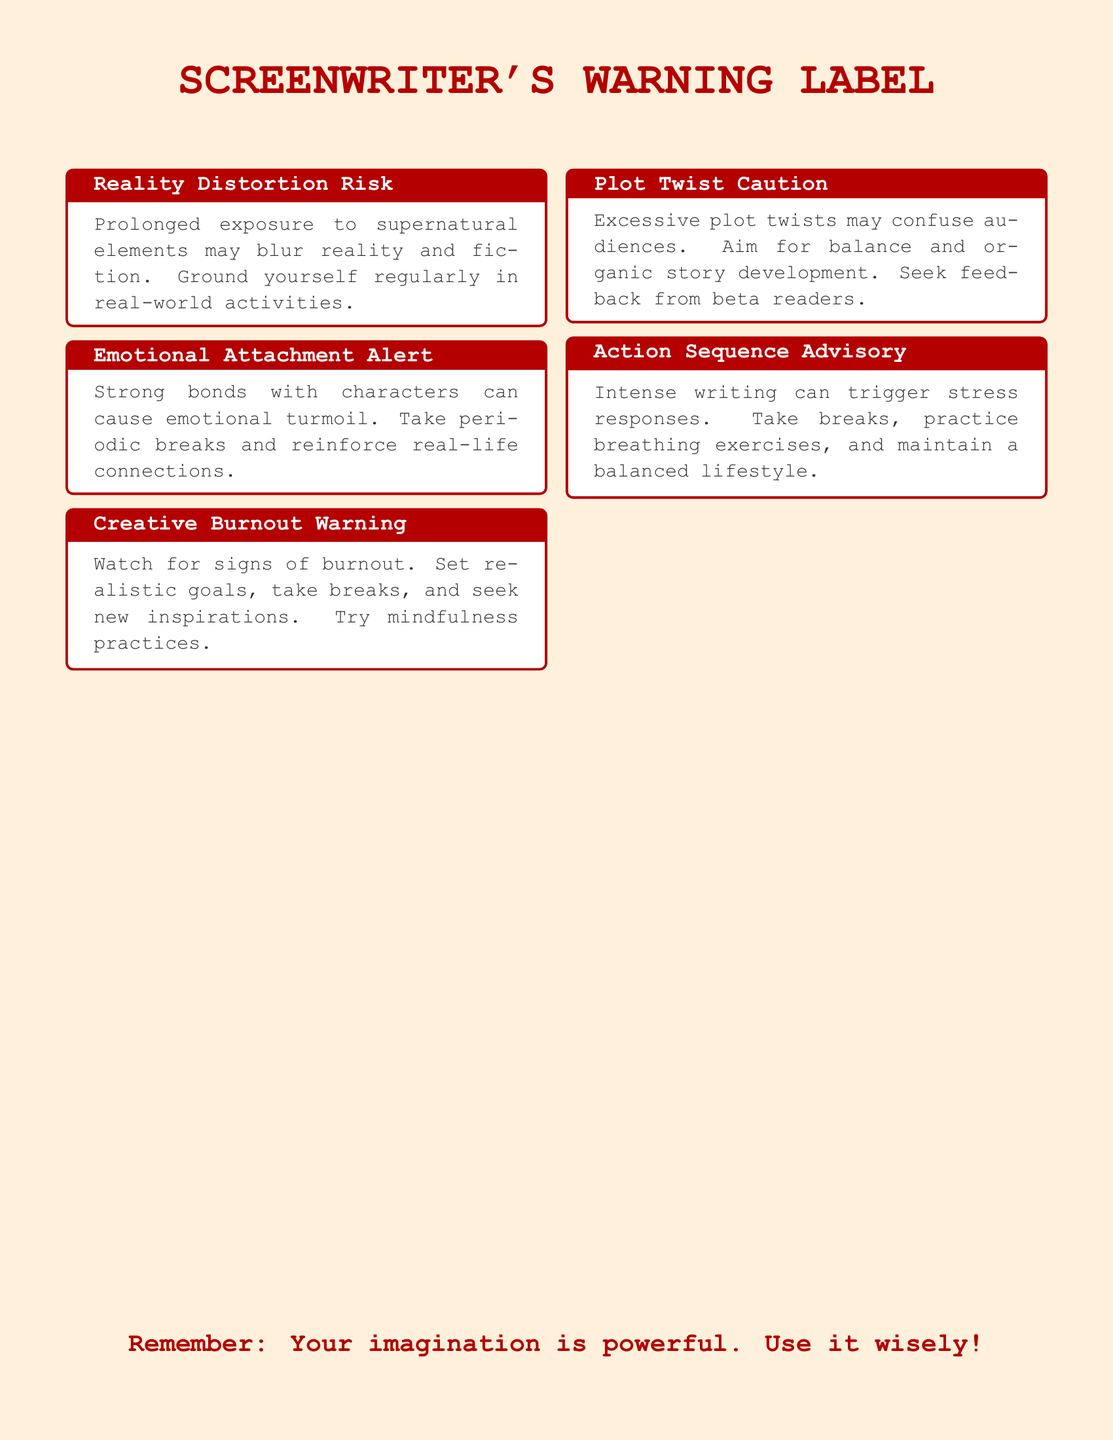What is the title of the warning label? The title is prominently displayed at the top of the document, stating "SCREENWRITER'S WARNING LABEL".
Answer: SCREENWRITER'S WARNING LABEL How many sections are in the warning label? The document contains five distinct sections, each addressing a specific warning.
Answer: 5 What is the main color used for the background? The background color is specified in the document setup as a light warning color.
Answer: light orange What advice is given for avoiding emotional turmoil? The suggestion involves taking periodic breaks to maintain a healthy perspective.
Answer: Take periodic breaks What type of writing can trigger stress responses? This refers to "intense writing," specifically related to high-action sequences.
Answer: Intense writing What should writers seek from beta readers regarding plot twists? It advises that writers should seek feedback on their plot twists to ensure clarity.
Answer: Feedback Which mindfulness practice is recommended for burnout? The document suggests mindfulness practices as a method to counteract burnout.
Answer: Mindfulness practices What is advised for coping with excessive plot twists? The guideline states to aim for balance and ensure organic story development.
Answer: Balance What is one coping mechanism mentioned for action sequences? A recommended coping mechanism involves practicing breathing exercises.
Answer: Breathing exercises 